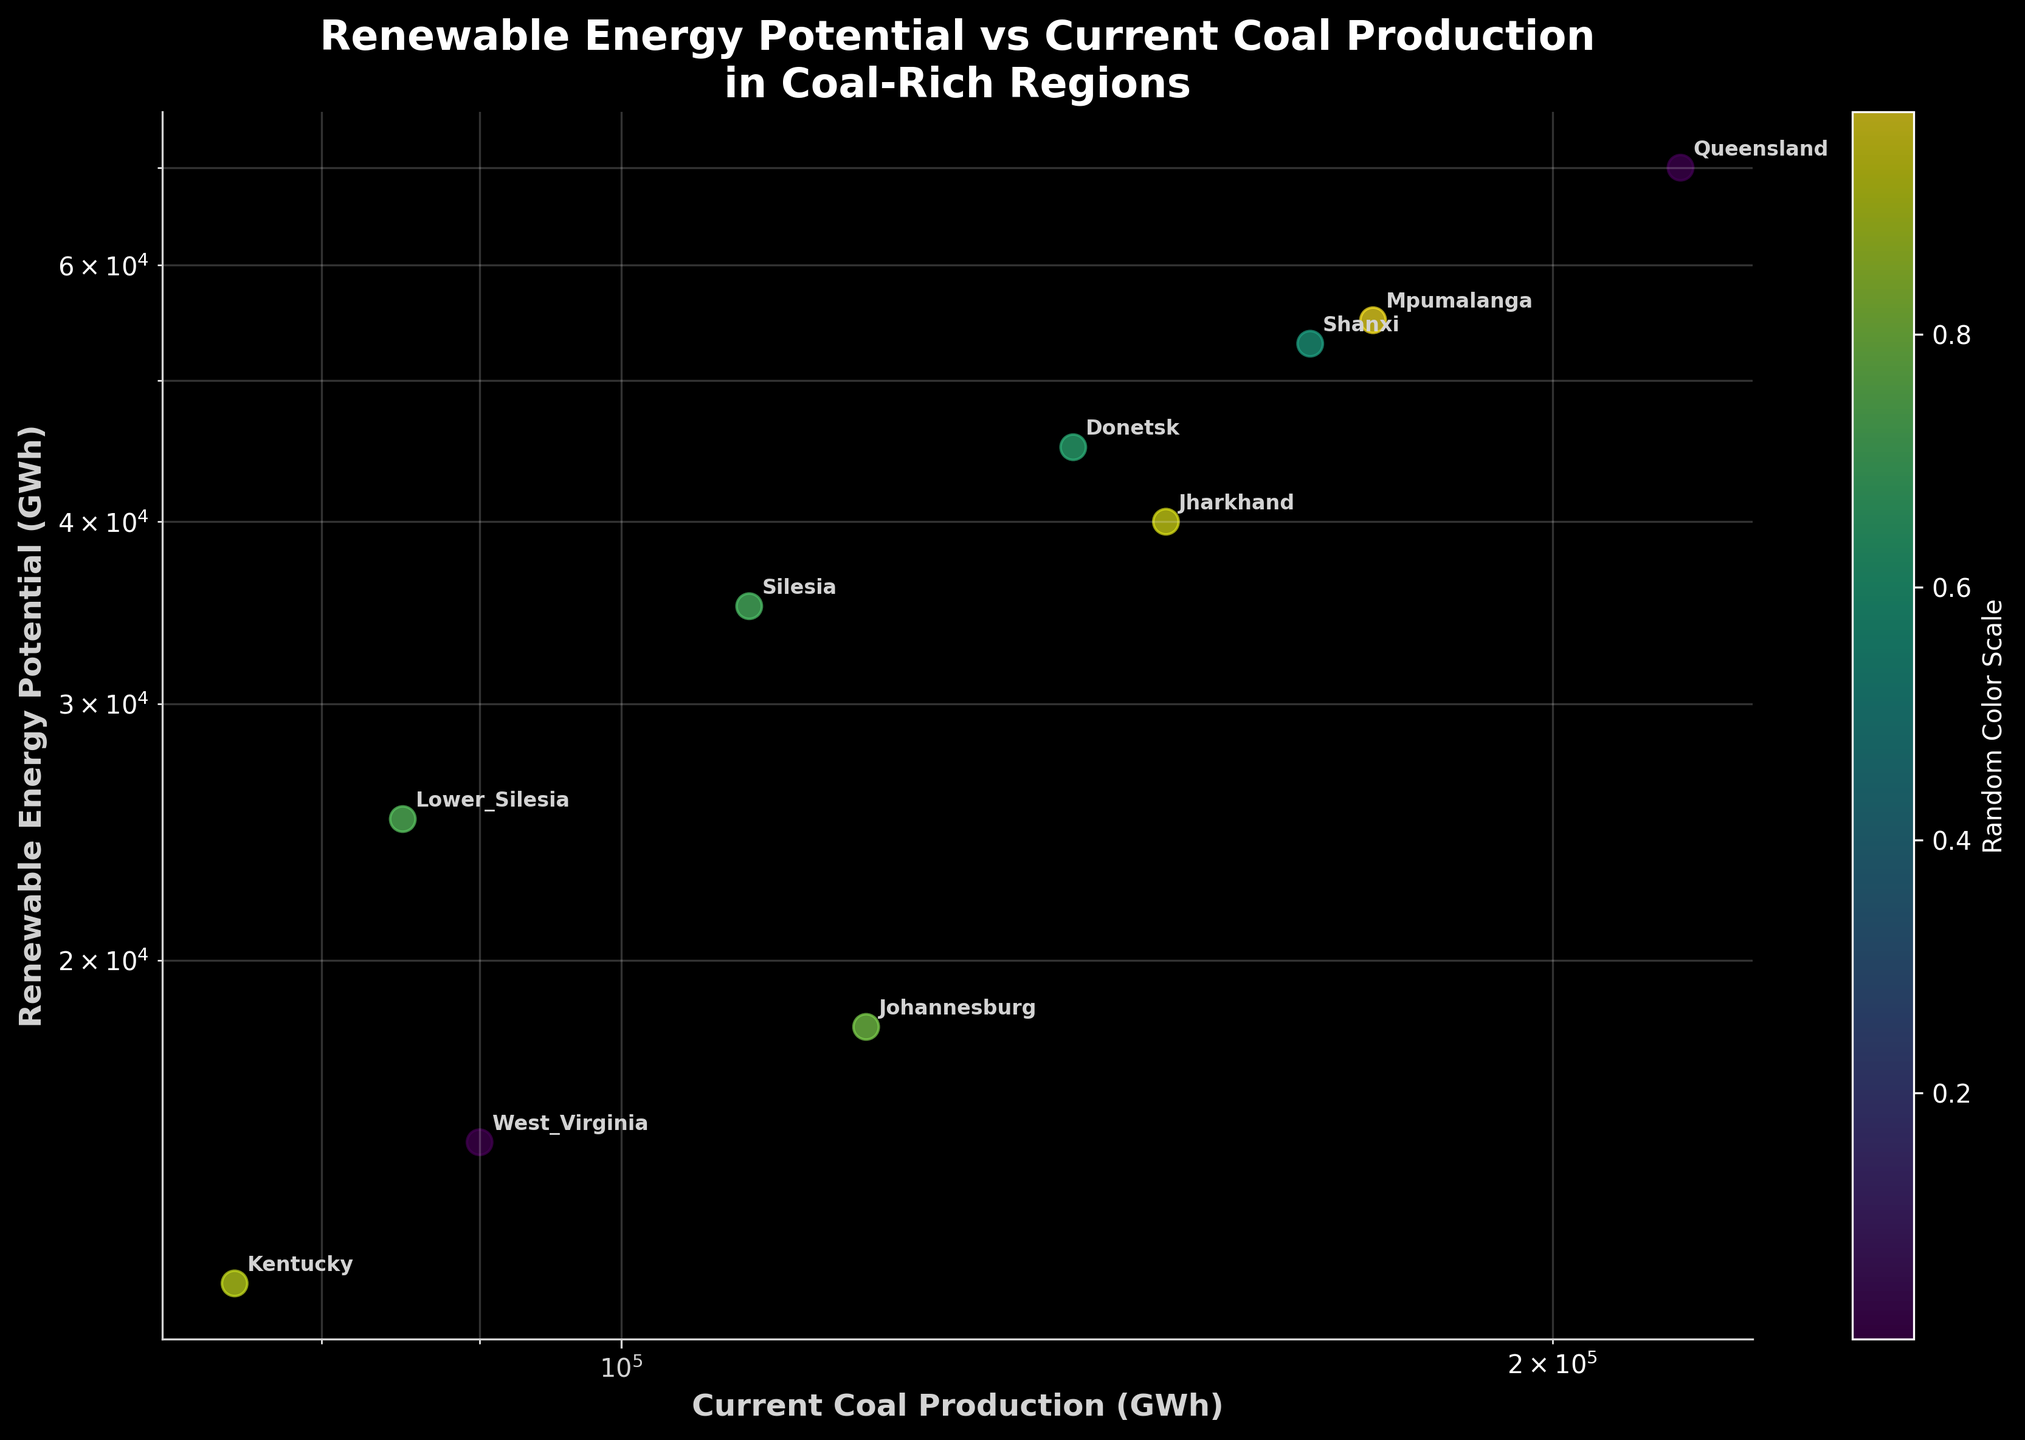What is the title of the plot? The title is written in large, bold white text at the top of the plot and reads "Renewable Energy Potential vs Current Coal Production\nin Coal-Rich Regions".
Answer: Renewable Energy Potential vs Current Coal Production in Coal-Rich Regions What is the x-axis label of the plot? The x-axis label can be found at the bottom of the plot in bold, light gray text and reads "Current Coal Production (GWh)".
Answer: Current Coal Production (GWh) How many data points are there in the plot? To determine the number of data points, count the number of annotated regions or colored dots on the plot. There are 10 regions listed, which means there are 10 data points.
Answer: 10 Which region has the highest current coal production? By examining the x-axis on the logarithmic scale and identifying the data point furthest to the right, the region with the highest coal production is Queensland with 220,000 GWh.
Answer: Queensland Which region has the lowest renewable energy potential? Looking at the y-axis on the logarithmic scale and finding the data point lowest down, West Virginia has the lowest renewable energy potential with 15,000 GWh.
Answer: West Virginia Compare the renewable energy potential between Shanxi and Mpumalanga. Which one is higher and by how much? Shanxi has 53,000 GWh of renewable potential while Mpumalanga has 55,000 GWh. To find the difference, subtract the smaller value from the larger value: 55,000 - 53,000 = 2,000 GWh.
Answer: Mpumalanga, by 2,000 GWh What is the median value of current coal production among all listed regions? First, list all the values of current coal production in ascending order: 75,000 (Kentucky), 85,000 (Lower Silesia), 90,000 (West Virginia), 110,000 (Silesia), 120,000 (Johannesburg), 140,000 (Donetsk), 150,000 (Jharkhand), 167,000 (Shanxi), 175,000 (Mpumalanga), 220,000 (Queensland). With 10 data points, the median is the average of the 5th and 6th values: (120,000 + 140,000) / 2 = 130,000 GWh.
Answer: 130,000 GWh Between Jharkhand and Donetsk, which region has a higher renewable energy potential and by what percentage is it higher? Jharkhand has 40,000 GWh while Donetsk has 45,000 GWh. First, find the difference: 45,000 - 40,000 = 5,000. Then, calculate the percentage increase relative to Jharkhand: (5,000 / 40,000) * 100 = 12.5%.
Answer: Donetsk, by 12.5% Does Silesia have a higher renewable energy potential than Kentucky? If so, by how much? Silesia has 35,000 GWh of renewable energy potential, while Kentucky has 12,000 GWh. Subtract Kentucky's value from Silesia's: 35,000 - 12,000 = 23,000 GWh.
Answer: Yes, by 23,000 GWh Are there more regions with current coal production above 100,000 GWh or below 100,000 GWh? Count the regions with coal production above 100,000 GWh: Shanxi, Queensland, Johannesburg, Silesia, Jharkhand, Mpumalanga, Donetsk (7 regions). Count the regions with production below 100,000 GWh: West Virginia, Lower Silesia, Kentucky (3 regions).
Answer: Above 100,000 GWh 